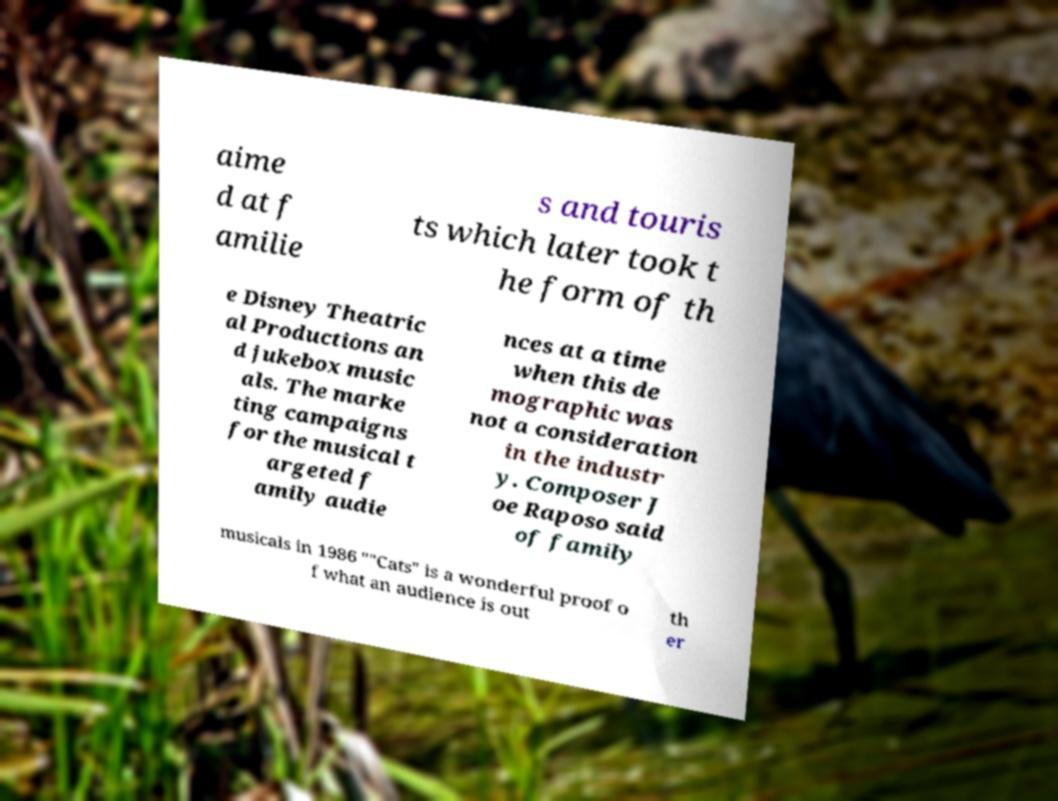Please identify and transcribe the text found in this image. aime d at f amilie s and touris ts which later took t he form of th e Disney Theatric al Productions an d jukebox music als. The marke ting campaigns for the musical t argeted f amily audie nces at a time when this de mographic was not a consideration in the industr y. Composer J oe Raposo said of family musicals in 1986 ""Cats" is a wonderful proof o f what an audience is out th er 